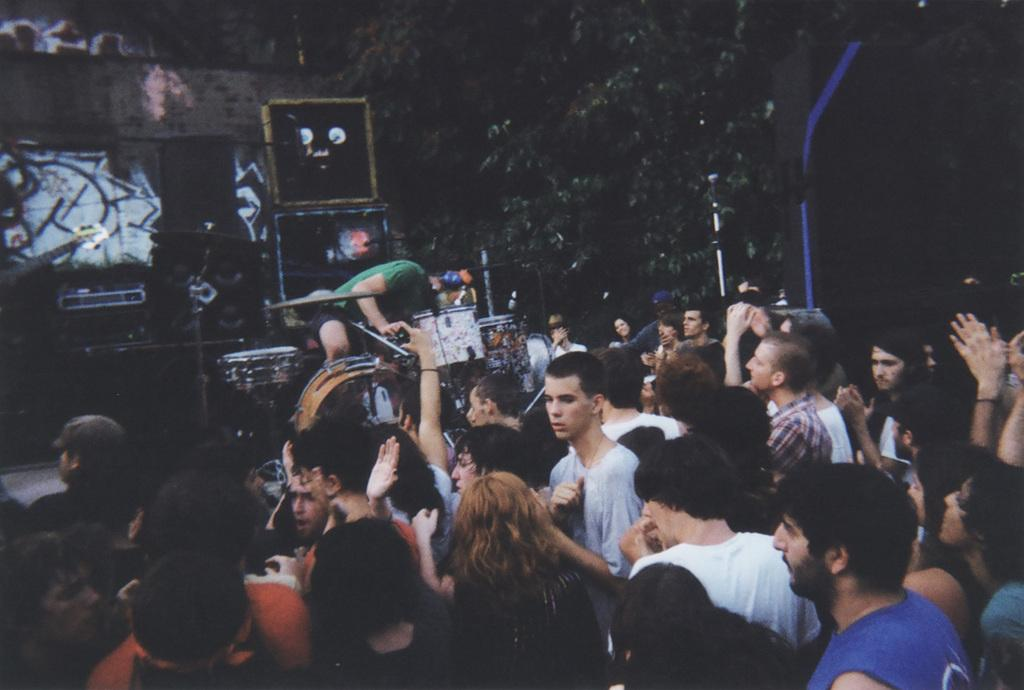What is the main activity being performed in the image? There is a person playing the drums in the image. Where is the person playing the drums located? The person is on a dais. Are there any other people present in the image? Yes, there are other people around the person playing the drums. What else can be seen in the image related to music? There are musical instruments in the image. Can you see the person playing the drums smiling in the image? The provided facts do not mention the facial expression of the person playing the drums, so it cannot be determined if they are smiling or not. 